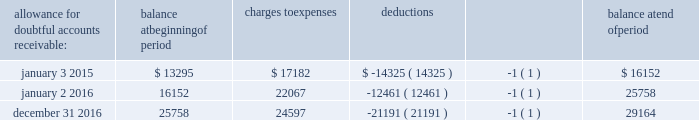Advance auto parts , inc .
Schedule ii - valuation and qualifying accounts ( in thousands ) allowance for doubtful accounts receivable : balance at beginning of period charges to expenses deductions balance at end of period january 3 , 2015 $ 13295 $ 17182 $ ( 14325 ) ( 1 ) $ 16152 january 2 , 2016 16152 22067 ( 12461 ) ( 1 ) 25758 december 31 , 2016 25758 24597 ( 21191 ) ( 1 ) 29164 ( 1 ) accounts written off during the period .
These amounts did not impact the company 2019s statement of operations for any year presented .
Note : other valuation and qualifying accounts have not been reported in this schedule because they are either not applicable or because the information has been included elsewhere in this report. .
Advance auto parts , inc .
Schedule ii - valuation and qualifying accounts ( in thousands ) allowance for doubtful accounts receivable : balance at beginning of period charges to expenses deductions balance at end of period january 3 , 2015 $ 13295 $ 17182 $ ( 14325 ) ( 1 ) $ 16152 january 2 , 2016 16152 22067 ( 12461 ) ( 1 ) 25758 december 31 , 2016 25758 24597 ( 21191 ) ( 1 ) 29164 ( 1 ) accounts written off during the period .
These amounts did not impact the company 2019s statement of operations for any year presented .
Note : other valuation and qualifying accounts have not been reported in this schedule because they are either not applicable or because the information has been included elsewhere in this report. .
What is the percentage change in the balance of allowance for doubtful accounts receivable during 2015? 
Computations: ((16152 - 13295) / 13295)
Answer: 0.21489. Advance auto parts , inc .
Schedule ii - valuation and qualifying accounts ( in thousands ) allowance for doubtful accounts receivable : balance at beginning of period charges to expenses deductions balance at end of period january 3 , 2015 $ 13295 $ 17182 $ ( 14325 ) ( 1 ) $ 16152 january 2 , 2016 16152 22067 ( 12461 ) ( 1 ) 25758 december 31 , 2016 25758 24597 ( 21191 ) ( 1 ) 29164 ( 1 ) accounts written off during the period .
These amounts did not impact the company 2019s statement of operations for any year presented .
Note : other valuation and qualifying accounts have not been reported in this schedule because they are either not applicable or because the information has been included elsewhere in this report. .
Advance auto parts , inc .
Schedule ii - valuation and qualifying accounts ( in thousands ) allowance for doubtful accounts receivable : balance at beginning of period charges to expenses deductions balance at end of period january 3 , 2015 $ 13295 $ 17182 $ ( 14325 ) ( 1 ) $ 16152 january 2 , 2016 16152 22067 ( 12461 ) ( 1 ) 25758 december 31 , 2016 25758 24597 ( 21191 ) ( 1 ) 29164 ( 1 ) accounts written off during the period .
These amounts did not impact the company 2019s statement of operations for any year presented .
Note : other valuation and qualifying accounts have not been reported in this schedule because they are either not applicable or because the information has been included elsewhere in this report. .
What is the net increase in the balance of allowance for doubtful accounts receivable during 2015? 
Computations: (16152 - 13295)
Answer: 2857.0. Advance auto parts , inc .
Schedule ii - valuation and qualifying accounts ( in thousands ) allowance for doubtful accounts receivable : balance at beginning of period charges to expenses deductions balance at end of period january 3 , 2015 $ 13295 $ 17182 $ ( 14325 ) ( 1 ) $ 16152 january 2 , 2016 16152 22067 ( 12461 ) ( 1 ) 25758 december 31 , 2016 25758 24597 ( 21191 ) ( 1 ) 29164 ( 1 ) accounts written off during the period .
These amounts did not impact the company 2019s statement of operations for any year presented .
Note : other valuation and qualifying accounts have not been reported in this schedule because they are either not applicable or because the information has been included elsewhere in this report. .
Advance auto parts , inc .
Schedule ii - valuation and qualifying accounts ( in thousands ) allowance for doubtful accounts receivable : balance at beginning of period charges to expenses deductions balance at end of period january 3 , 2015 $ 13295 $ 17182 $ ( 14325 ) ( 1 ) $ 16152 january 2 , 2016 16152 22067 ( 12461 ) ( 1 ) 25758 december 31 , 2016 25758 24597 ( 21191 ) ( 1 ) 29164 ( 1 ) accounts written off during the period .
These amounts did not impact the company 2019s statement of operations for any year presented .
Note : other valuation and qualifying accounts have not been reported in this schedule because they are either not applicable or because the information has been included elsewhere in this report. .
What percentage did the allowance for doubtful accounts receivables increase from the beginning of 2015 to the end of 2016? 
Rationale: to find the increase in allowance for doubtful accounts receivables one must subtract the begging of the year by the end of the year . then divide the answer by the beginning of the year .
Computations: ((29164 - 13295) / 13295)
Answer: 1.19361. 